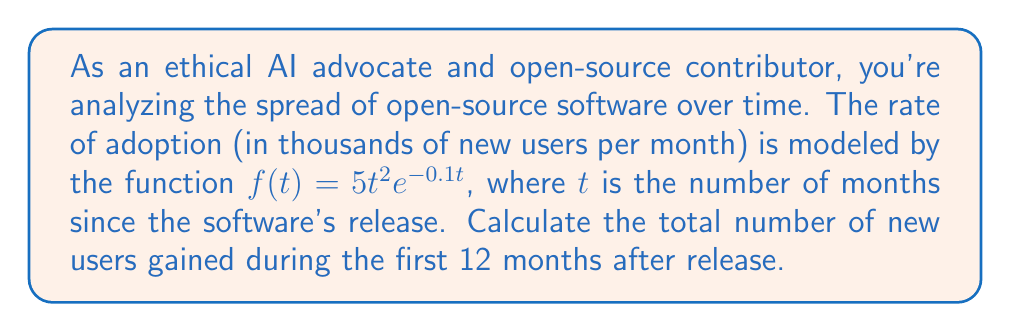Provide a solution to this math problem. To find the total number of new users gained during the first 12 months, we need to integrate the rate function $f(t)$ from $t=0$ to $t=12$. This will give us the area under the curve, which represents the cumulative number of new users.

1. Set up the definite integral:
   $$\int_0^{12} 5t^2e^{-0.1t} dt$$

2. This integral cannot be solved using elementary antiderivatives. We'll use integration by parts twice.
   Let $u = t^2$ and $dv = e^{-0.1t}dt$

3. First integration by parts:
   $$\int t^2e^{-0.1t} dt = -10t^2e^{-0.1t} + 20\int te^{-0.1t} dt$$

4. Second integration by parts (for the remaining integral):
   $$20\int te^{-0.1t} dt = -200te^{-0.1t} + 2000\int e^{-0.1t} dt$$

5. Solve the final integral:
   $$2000\int e^{-0.1t} dt = -20000e^{-0.1t}$$

6. Combine all terms:
   $$\int t^2e^{-0.1t} dt = -10t^2e^{-0.1t} - 200te^{-0.1t} - 20000e^{-0.1t} + C$$

7. Apply the limits of integration:
   $$\left[-10t^2e^{-0.1t} - 200te^{-0.1t} - 20000e^{-0.1t}\right]_0^{12}$$

8. Evaluate at $t=12$ and $t=0$:
   $$(-10(12^2)e^{-1.2} - 200(12)e^{-1.2} - 20000e^{-1.2}) - (-10(0^2)e^0 - 200(0)e^0 - 20000e^0)$$

9. Simplify:
   $$(-1440e^{-1.2} - 2400e^{-1.2} - 20000e^{-1.2}) - (-20000)$$

10. Calculate the final result:
    $$20000 - (1440 + 2400 + 20000)e^{-1.2} \approx 4986.58$$

The result is in thousands of users, so we multiply by 1000 to get the actual number of users.
Answer: 4,986,580 users 